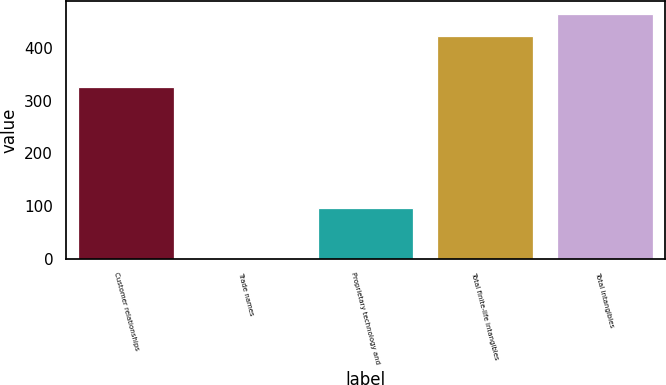<chart> <loc_0><loc_0><loc_500><loc_500><bar_chart><fcel>Customer relationships<fcel>Trade names<fcel>Proprietary technology and<fcel>Total finite-life intangibles<fcel>Total intangibles<nl><fcel>325.2<fcel>1.1<fcel>96.7<fcel>423<fcel>465.19<nl></chart> 